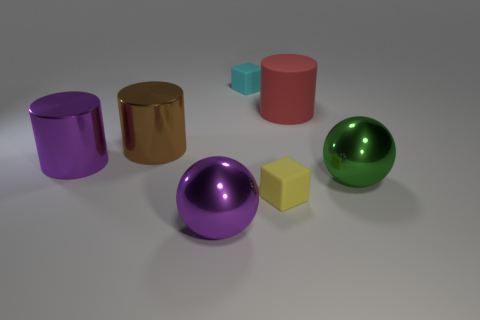Add 2 tiny green rubber balls. How many objects exist? 9 Subtract all cubes. How many objects are left? 5 Add 1 large green balls. How many large green balls are left? 2 Add 3 large spheres. How many large spheres exist? 5 Subtract 0 cyan balls. How many objects are left? 7 Subtract all purple shiny cubes. Subtract all big red cylinders. How many objects are left? 6 